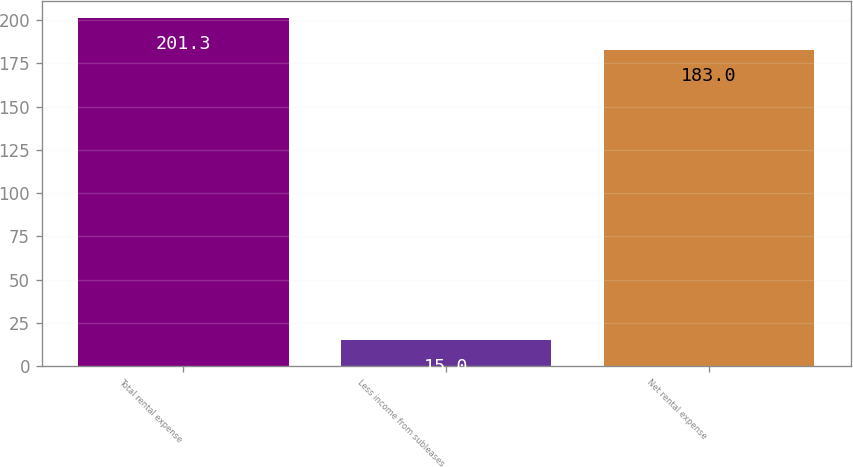<chart> <loc_0><loc_0><loc_500><loc_500><bar_chart><fcel>Total rental expense<fcel>Less income from subleases<fcel>Net rental expense<nl><fcel>201.3<fcel>15<fcel>183<nl></chart> 